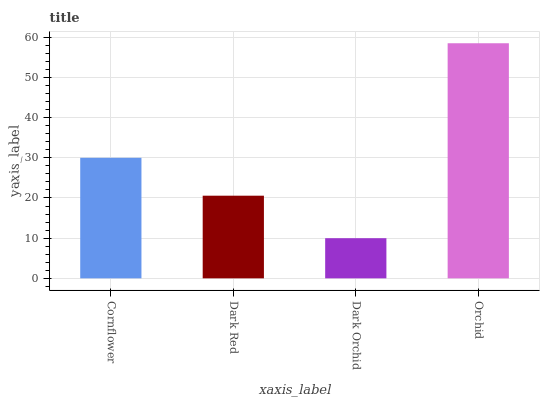Is Dark Orchid the minimum?
Answer yes or no. Yes. Is Orchid the maximum?
Answer yes or no. Yes. Is Dark Red the minimum?
Answer yes or no. No. Is Dark Red the maximum?
Answer yes or no. No. Is Cornflower greater than Dark Red?
Answer yes or no. Yes. Is Dark Red less than Cornflower?
Answer yes or no. Yes. Is Dark Red greater than Cornflower?
Answer yes or no. No. Is Cornflower less than Dark Red?
Answer yes or no. No. Is Cornflower the high median?
Answer yes or no. Yes. Is Dark Red the low median?
Answer yes or no. Yes. Is Orchid the high median?
Answer yes or no. No. Is Cornflower the low median?
Answer yes or no. No. 